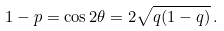<formula> <loc_0><loc_0><loc_500><loc_500>1 - p = \cos 2 \theta = 2 \sqrt { q ( 1 - q ) } \, .</formula> 